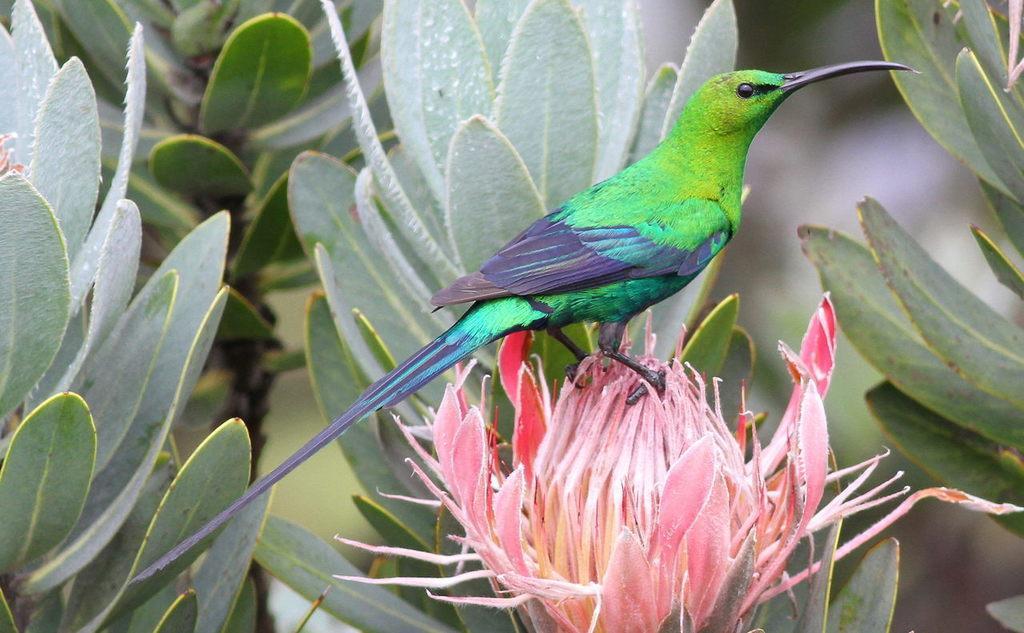Describe this image in one or two sentences. In this image we can see a bird on a flower and trees in the background. 